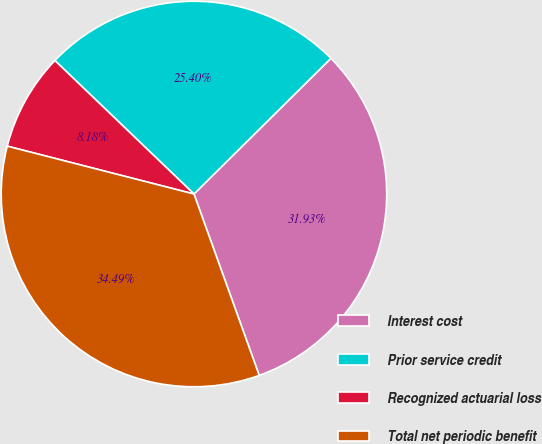Convert chart to OTSL. <chart><loc_0><loc_0><loc_500><loc_500><pie_chart><fcel>Interest cost<fcel>Prior service credit<fcel>Recognized actuarial loss<fcel>Total net periodic benefit<nl><fcel>31.93%<fcel>25.4%<fcel>8.18%<fcel>34.49%<nl></chart> 